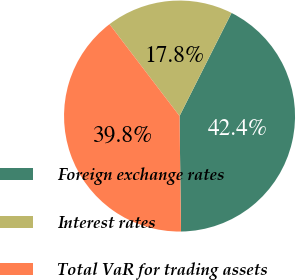<chart> <loc_0><loc_0><loc_500><loc_500><pie_chart><fcel>Foreign exchange rates<fcel>Interest rates<fcel>Total VaR for trading assets<nl><fcel>42.37%<fcel>17.8%<fcel>39.83%<nl></chart> 